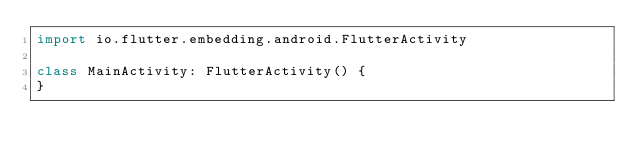<code> <loc_0><loc_0><loc_500><loc_500><_Kotlin_>import io.flutter.embedding.android.FlutterActivity

class MainActivity: FlutterActivity() {
}
</code> 